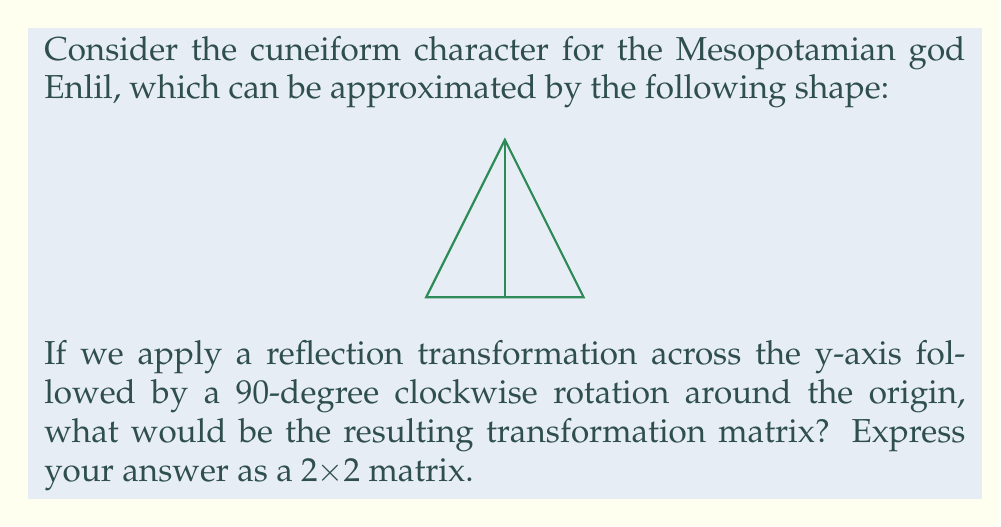Provide a solution to this math problem. Let's approach this step-by-step:

1) First, we need to recall the transformation matrices for reflection and rotation:

   Reflection across y-axis: $R_y = \begin{pmatrix} -1 & 0 \\ 0 & 1 \end{pmatrix}$

   90-degree clockwise rotation: $R_{90} = \begin{pmatrix} 0 & 1 \\ -1 & 0 \end{pmatrix}$

2) In transformation compositions, we apply the rightmost matrix first. So, we need to multiply these matrices in the order: rotation * reflection.

3) Let's perform the matrix multiplication:

   $$\begin{pmatrix} 0 & 1 \\ -1 & 0 \end{pmatrix} \begin{pmatrix} -1 & 0 \\ 0 & 1 \end{pmatrix}$$

4) Multiplying these matrices:
   
   $$(0 \cdot -1 + 1 \cdot 0) = 0 \quad (0 \cdot 0 + 1 \cdot 1) = 1$$
   $$(-1 \cdot -1 + 0 \cdot 0) = 1 \quad (-1 \cdot 0 + 0 \cdot 1) = 0$$

5) This gives us the resulting transformation matrix:

   $$\begin{pmatrix} 0 & 1 \\ 1 & 0 \end{pmatrix}$$

This matrix represents the combined transformation of reflection across the y-axis followed by a 90-degree clockwise rotation.
Answer: $$\begin{pmatrix} 0 & 1 \\ 1 & 0 \end{pmatrix}$$ 